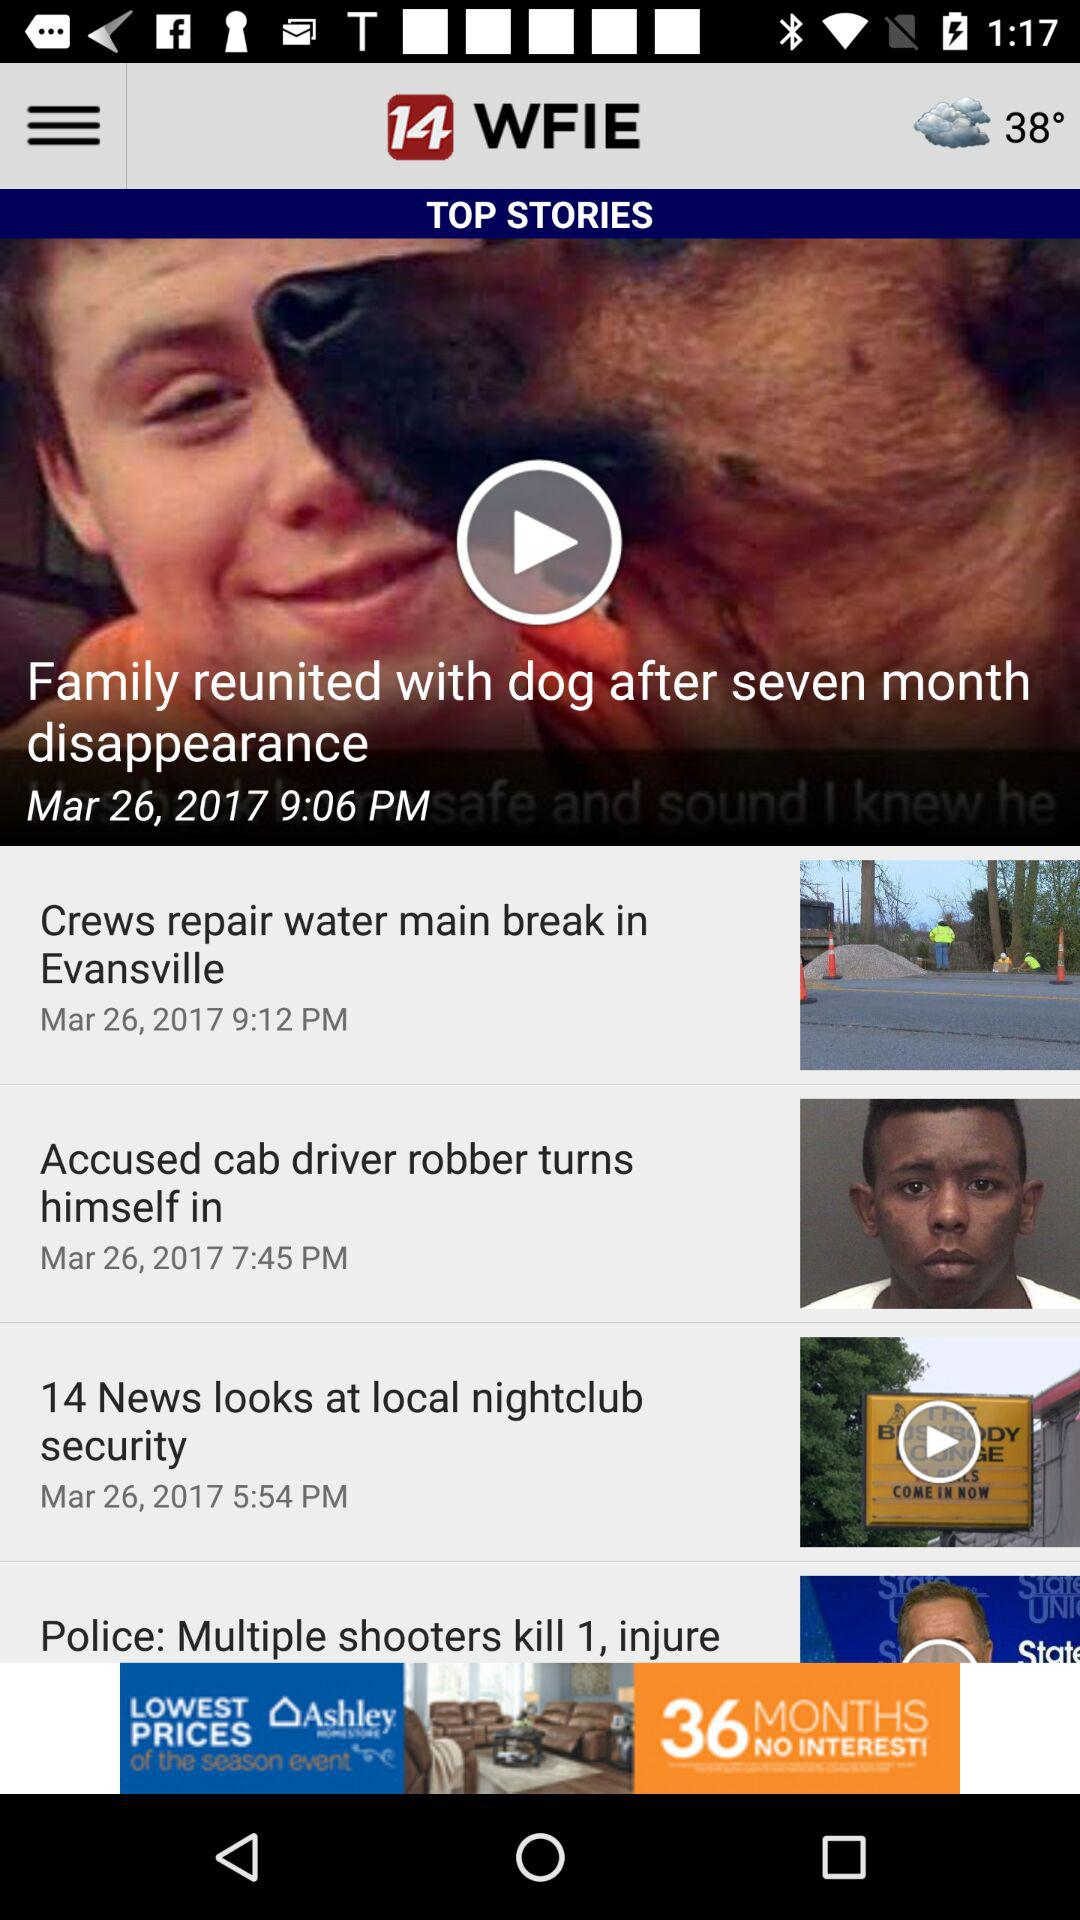On what date was the news "Accused cab driver robber turns himself in" posted? The news was posted on Mar 26, 2017. 